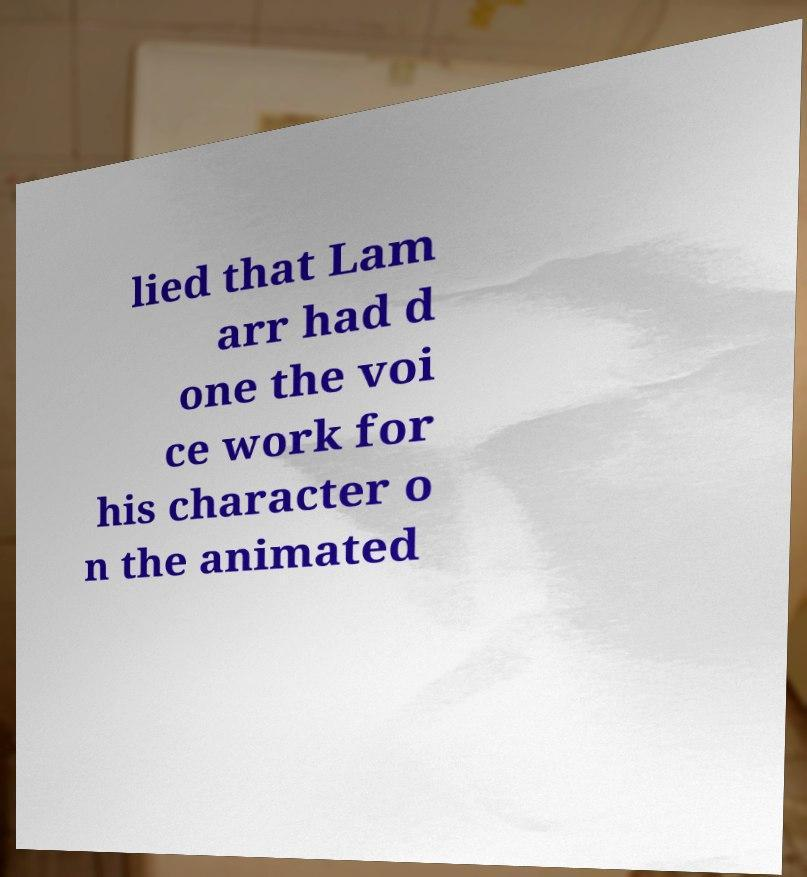I need the written content from this picture converted into text. Can you do that? lied that Lam arr had d one the voi ce work for his character o n the animated 